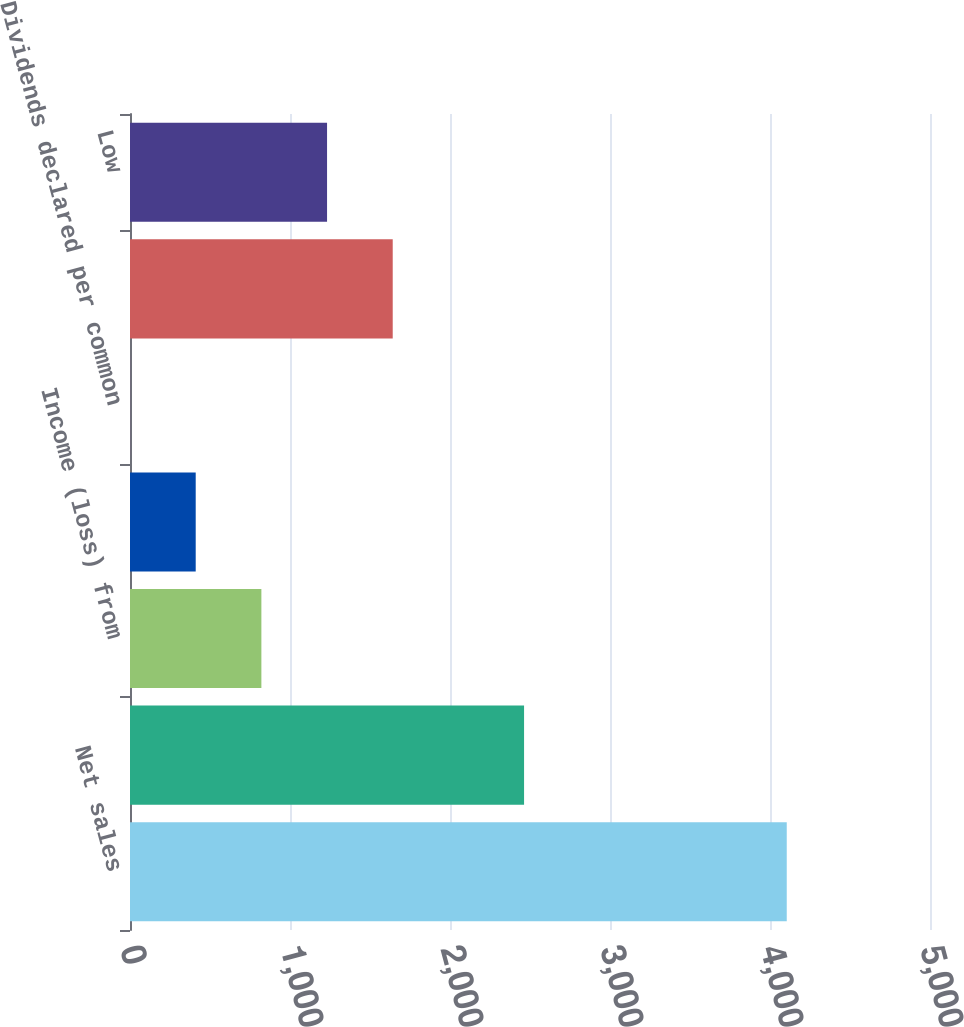Convert chart to OTSL. <chart><loc_0><loc_0><loc_500><loc_500><bar_chart><fcel>Net sales<fcel>Gross profit<fcel>Income (loss) from<fcel>Net income (loss) attributable<fcel>Dividends declared per common<fcel>High<fcel>Low<nl><fcel>4104.7<fcel>2462.91<fcel>821.13<fcel>410.69<fcel>0.25<fcel>1642.02<fcel>1231.58<nl></chart> 